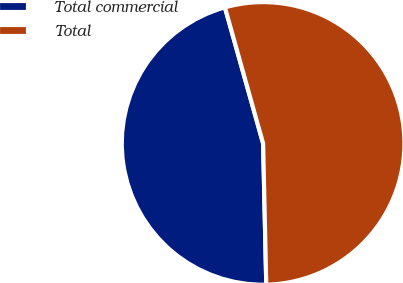Convert chart. <chart><loc_0><loc_0><loc_500><loc_500><pie_chart><fcel>Total commercial<fcel>Total<nl><fcel>46.0%<fcel>54.0%<nl></chart> 